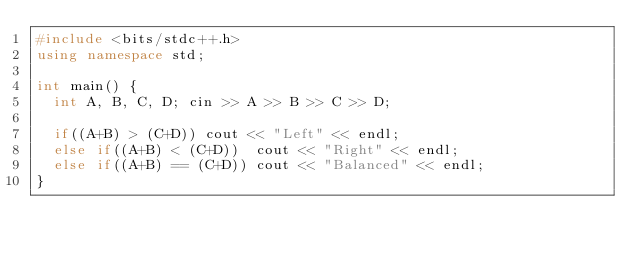Convert code to text. <code><loc_0><loc_0><loc_500><loc_500><_C++_>#include <bits/stdc++.h>
using namespace std;

int main() {
  int A, B, C, D;	cin >> A >> B >> C >> D;
  
  if((A+B) > (C+D))	cout << "Left" << endl;
  else if((A+B) < (C+D))	cout << "Right" << endl;
  else if((A+B) == (C+D))	cout << "Balanced" << endl;
}</code> 